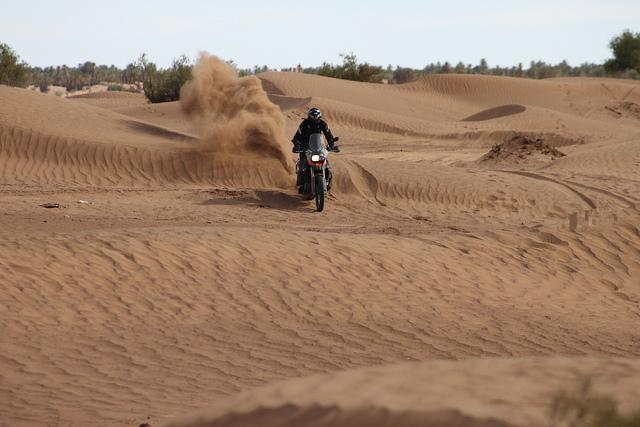Is the person kicking up dust?
Quick response, please. Yes. Is this a wet area?
Give a very brief answer. No. What is the person riding?
Be succinct. Motorcycle. 